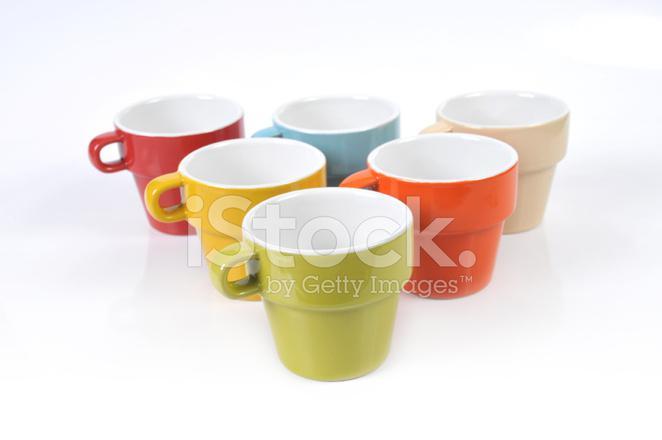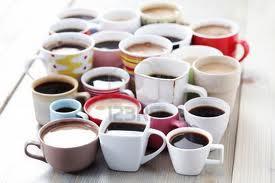The first image is the image on the left, the second image is the image on the right. Considering the images on both sides, is "There are more cups in the left image than in the right image." valid? Answer yes or no. No. The first image is the image on the left, the second image is the image on the right. Assess this claim about the two images: "Some of the cups are stacked one on top of another". Correct or not? Answer yes or no. No. 